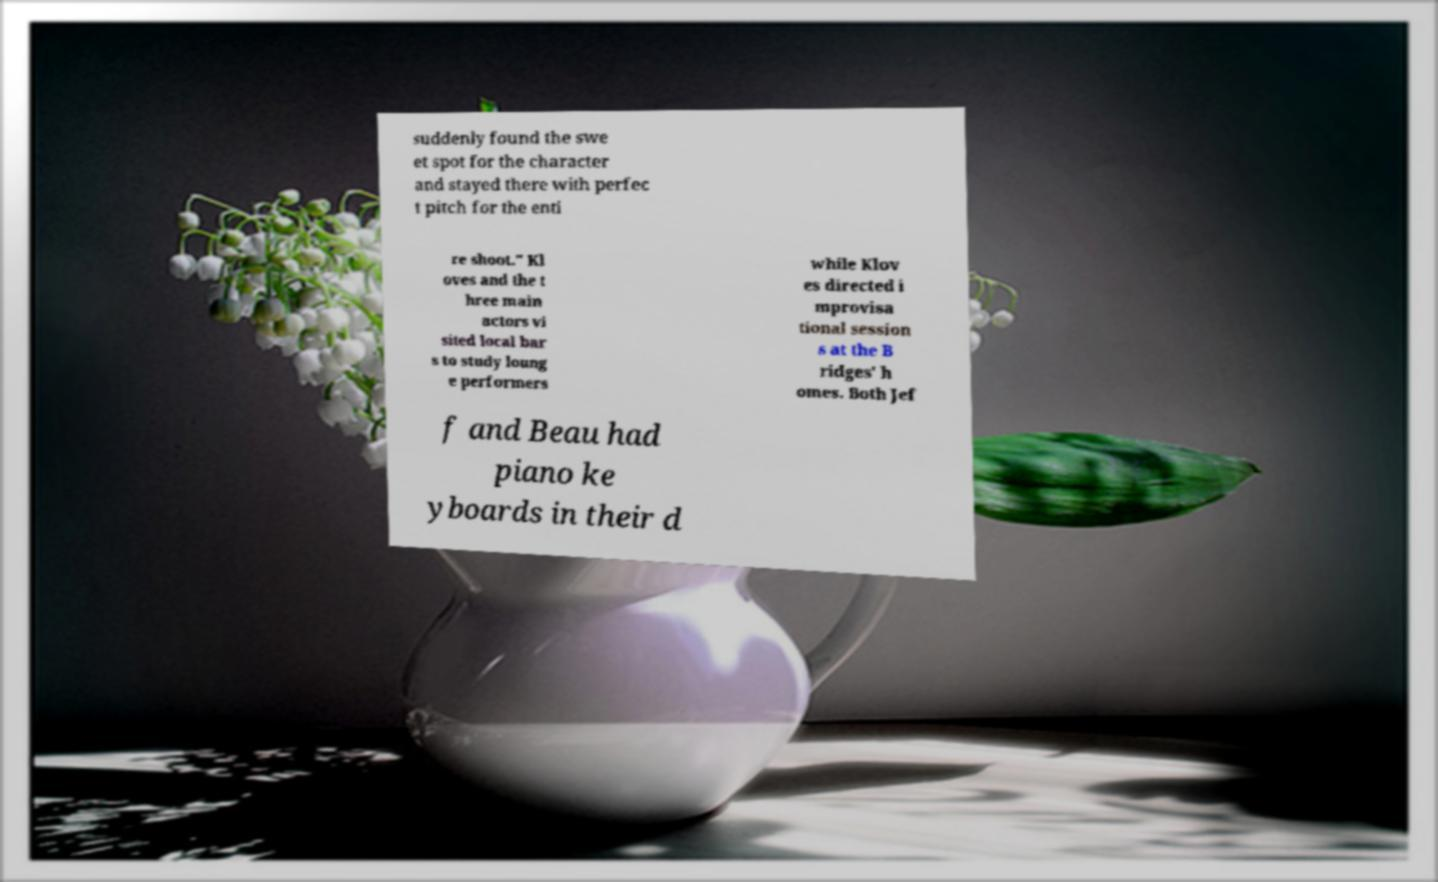Please read and relay the text visible in this image. What does it say? suddenly found the swe et spot for the character and stayed there with perfec t pitch for the enti re shoot." Kl oves and the t hree main actors vi sited local bar s to study loung e performers while Klov es directed i mprovisa tional session s at the B ridges' h omes. Both Jef f and Beau had piano ke yboards in their d 